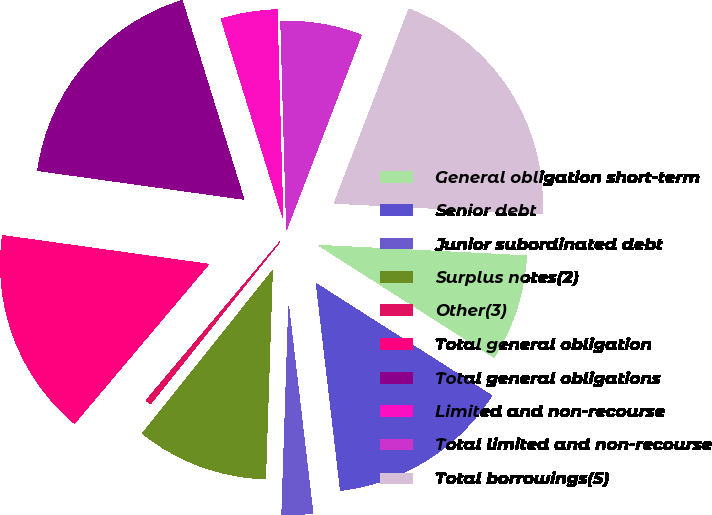Convert chart to OTSL. <chart><loc_0><loc_0><loc_500><loc_500><pie_chart><fcel>General obligation short-term<fcel>Senior debt<fcel>Junior subordinated debt<fcel>Surplus notes(2)<fcel>Other(3)<fcel>Total general obligation<fcel>Total general obligations<fcel>Limited and non-recourse<fcel>Total limited and non-recourse<fcel>Total borrowings(5)<nl><fcel>8.24%<fcel>14.1%<fcel>2.38%<fcel>10.2%<fcel>0.43%<fcel>16.05%<fcel>18.01%<fcel>4.34%<fcel>6.29%<fcel>19.96%<nl></chart> 